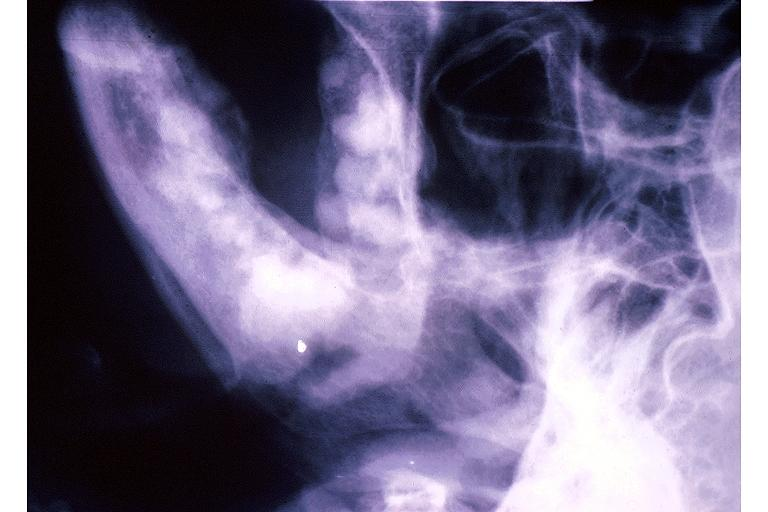s oral present?
Answer the question using a single word or phrase. Yes 